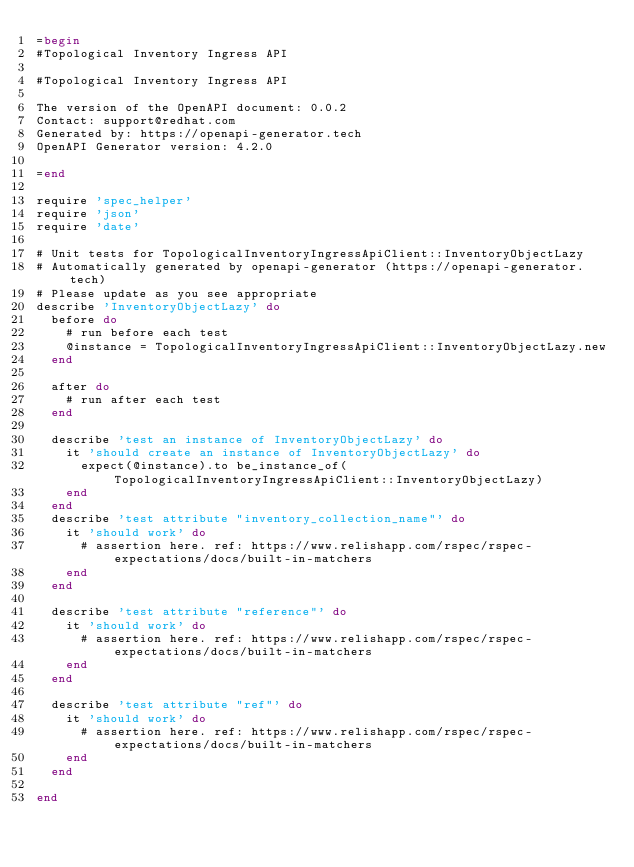<code> <loc_0><loc_0><loc_500><loc_500><_Ruby_>=begin
#Topological Inventory Ingress API

#Topological Inventory Ingress API

The version of the OpenAPI document: 0.0.2
Contact: support@redhat.com
Generated by: https://openapi-generator.tech
OpenAPI Generator version: 4.2.0

=end

require 'spec_helper'
require 'json'
require 'date'

# Unit tests for TopologicalInventoryIngressApiClient::InventoryObjectLazy
# Automatically generated by openapi-generator (https://openapi-generator.tech)
# Please update as you see appropriate
describe 'InventoryObjectLazy' do
  before do
    # run before each test
    @instance = TopologicalInventoryIngressApiClient::InventoryObjectLazy.new
  end

  after do
    # run after each test
  end

  describe 'test an instance of InventoryObjectLazy' do
    it 'should create an instance of InventoryObjectLazy' do
      expect(@instance).to be_instance_of(TopologicalInventoryIngressApiClient::InventoryObjectLazy)
    end
  end
  describe 'test attribute "inventory_collection_name"' do
    it 'should work' do
      # assertion here. ref: https://www.relishapp.com/rspec/rspec-expectations/docs/built-in-matchers
    end
  end

  describe 'test attribute "reference"' do
    it 'should work' do
      # assertion here. ref: https://www.relishapp.com/rspec/rspec-expectations/docs/built-in-matchers
    end
  end

  describe 'test attribute "ref"' do
    it 'should work' do
      # assertion here. ref: https://www.relishapp.com/rspec/rspec-expectations/docs/built-in-matchers
    end
  end

end
</code> 